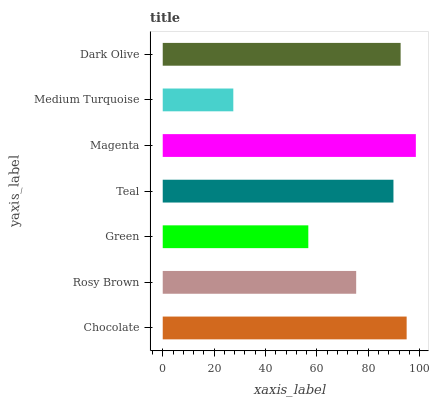Is Medium Turquoise the minimum?
Answer yes or no. Yes. Is Magenta the maximum?
Answer yes or no. Yes. Is Rosy Brown the minimum?
Answer yes or no. No. Is Rosy Brown the maximum?
Answer yes or no. No. Is Chocolate greater than Rosy Brown?
Answer yes or no. Yes. Is Rosy Brown less than Chocolate?
Answer yes or no. Yes. Is Rosy Brown greater than Chocolate?
Answer yes or no. No. Is Chocolate less than Rosy Brown?
Answer yes or no. No. Is Teal the high median?
Answer yes or no. Yes. Is Teal the low median?
Answer yes or no. Yes. Is Rosy Brown the high median?
Answer yes or no. No. Is Green the low median?
Answer yes or no. No. 